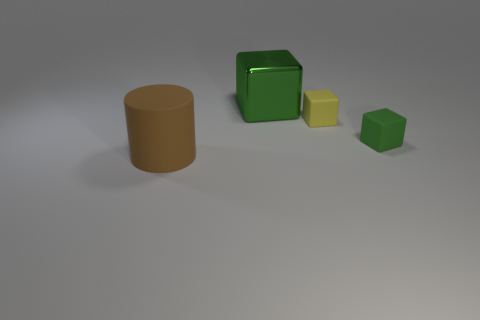Do the large object in front of the metallic object and the green block that is on the right side of the small yellow rubber cube have the same material?
Give a very brief answer. Yes. There is a big thing behind the big object on the left side of the big thing right of the big brown cylinder; what shape is it?
Offer a terse response. Cube. What is the shape of the big brown rubber object?
Your answer should be compact. Cylinder. What is the shape of the brown thing that is the same size as the green metallic cube?
Your answer should be very brief. Cylinder. How many other objects are there of the same color as the large metal thing?
Make the answer very short. 1. There is a big thing behind the big rubber cylinder; is its shape the same as the matte object that is behind the green matte object?
Make the answer very short. Yes. How many objects are either big things on the right side of the large brown rubber cylinder or large things that are in front of the green rubber cube?
Provide a short and direct response. 2. How many other things are there of the same material as the big green object?
Your response must be concise. 0. Are the thing on the left side of the green shiny thing and the big green thing made of the same material?
Your response must be concise. No. Is the number of big brown objects that are behind the small green block greater than the number of green objects in front of the big brown object?
Ensure brevity in your answer.  No. 